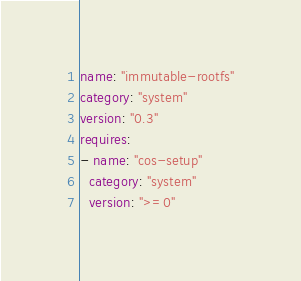Convert code to text. <code><loc_0><loc_0><loc_500><loc_500><_YAML_>name: "immutable-rootfs"
category: "system"
version: "0.3"
requires:
- name: "cos-setup"
  category: "system"
  version: ">=0"
</code> 